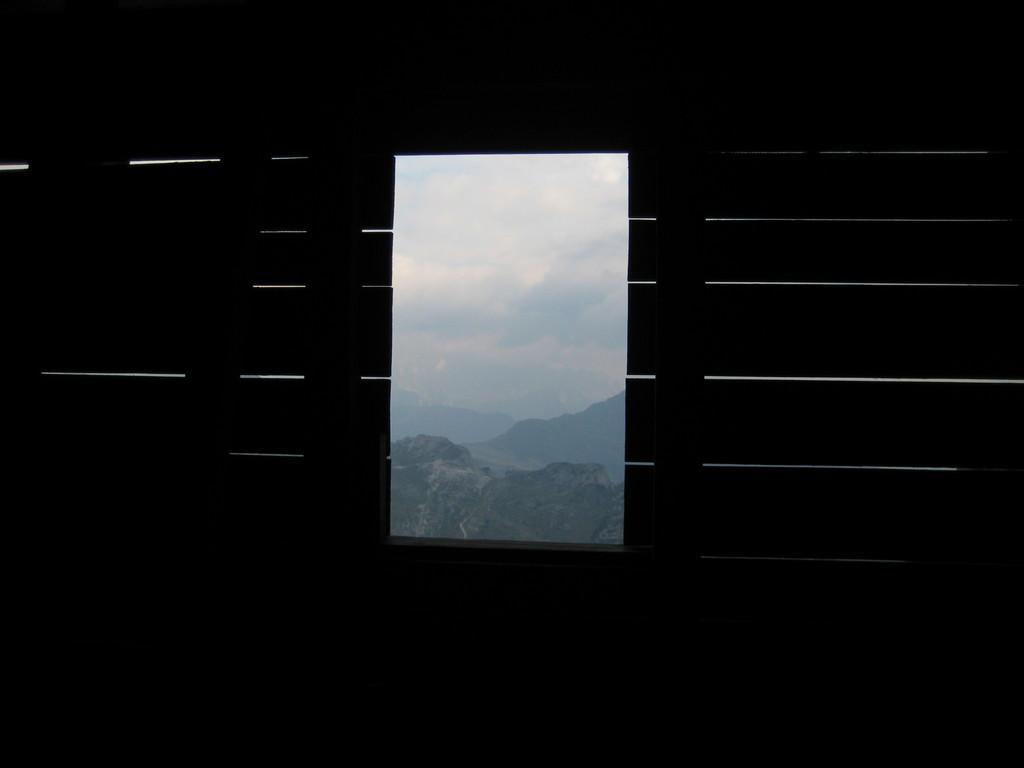Can you describe this image briefly? In this image I can see a window in the front and through the window I can see mountains, clouds and the sky. 